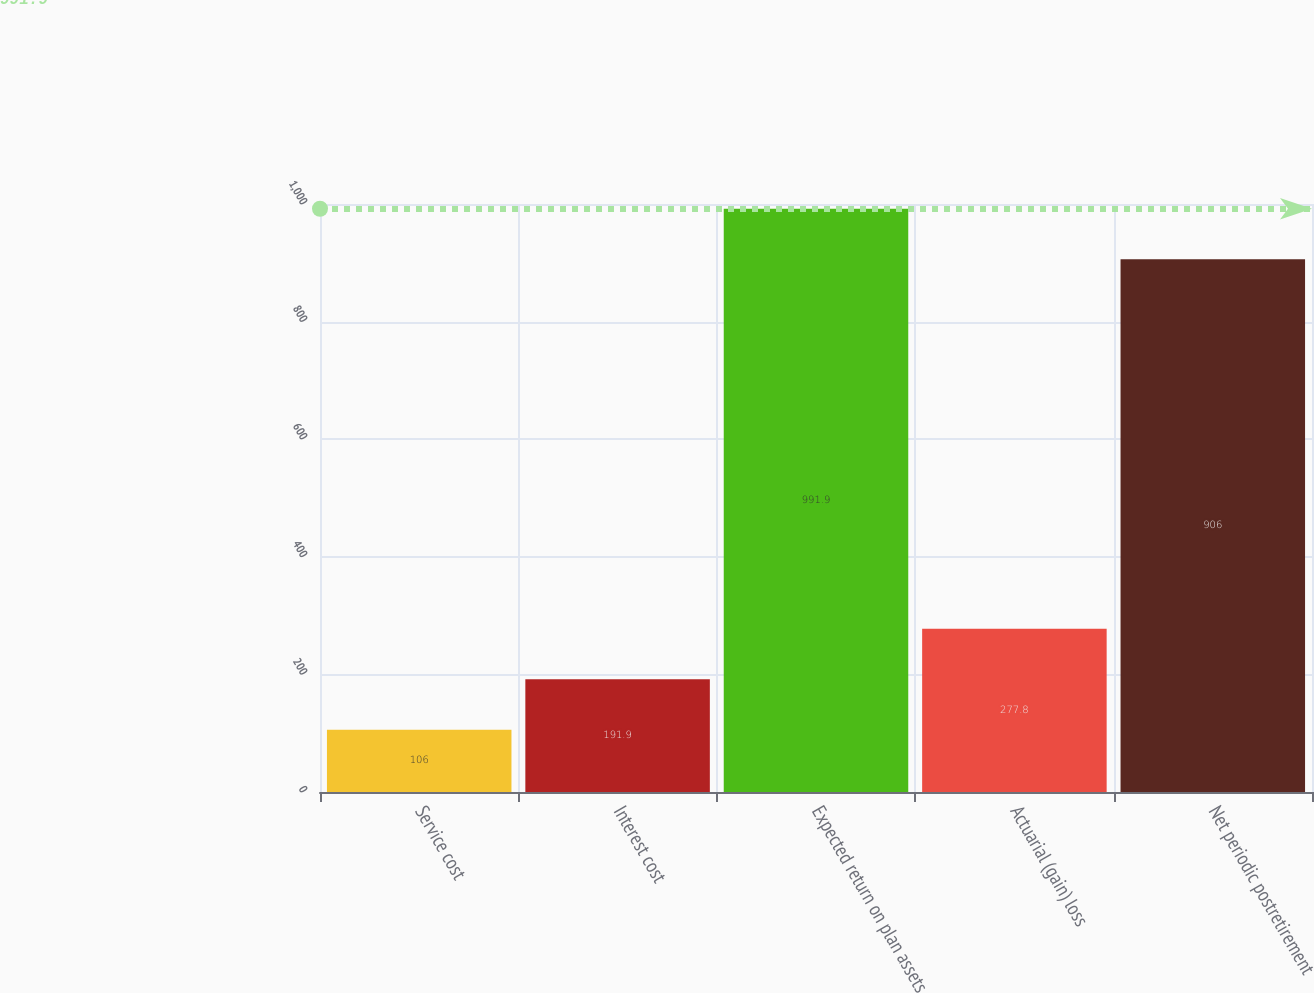<chart> <loc_0><loc_0><loc_500><loc_500><bar_chart><fcel>Service cost<fcel>Interest cost<fcel>Expected return on plan assets<fcel>Actuarial (gain) loss<fcel>Net periodic postretirement<nl><fcel>106<fcel>191.9<fcel>991.9<fcel>277.8<fcel>906<nl></chart> 